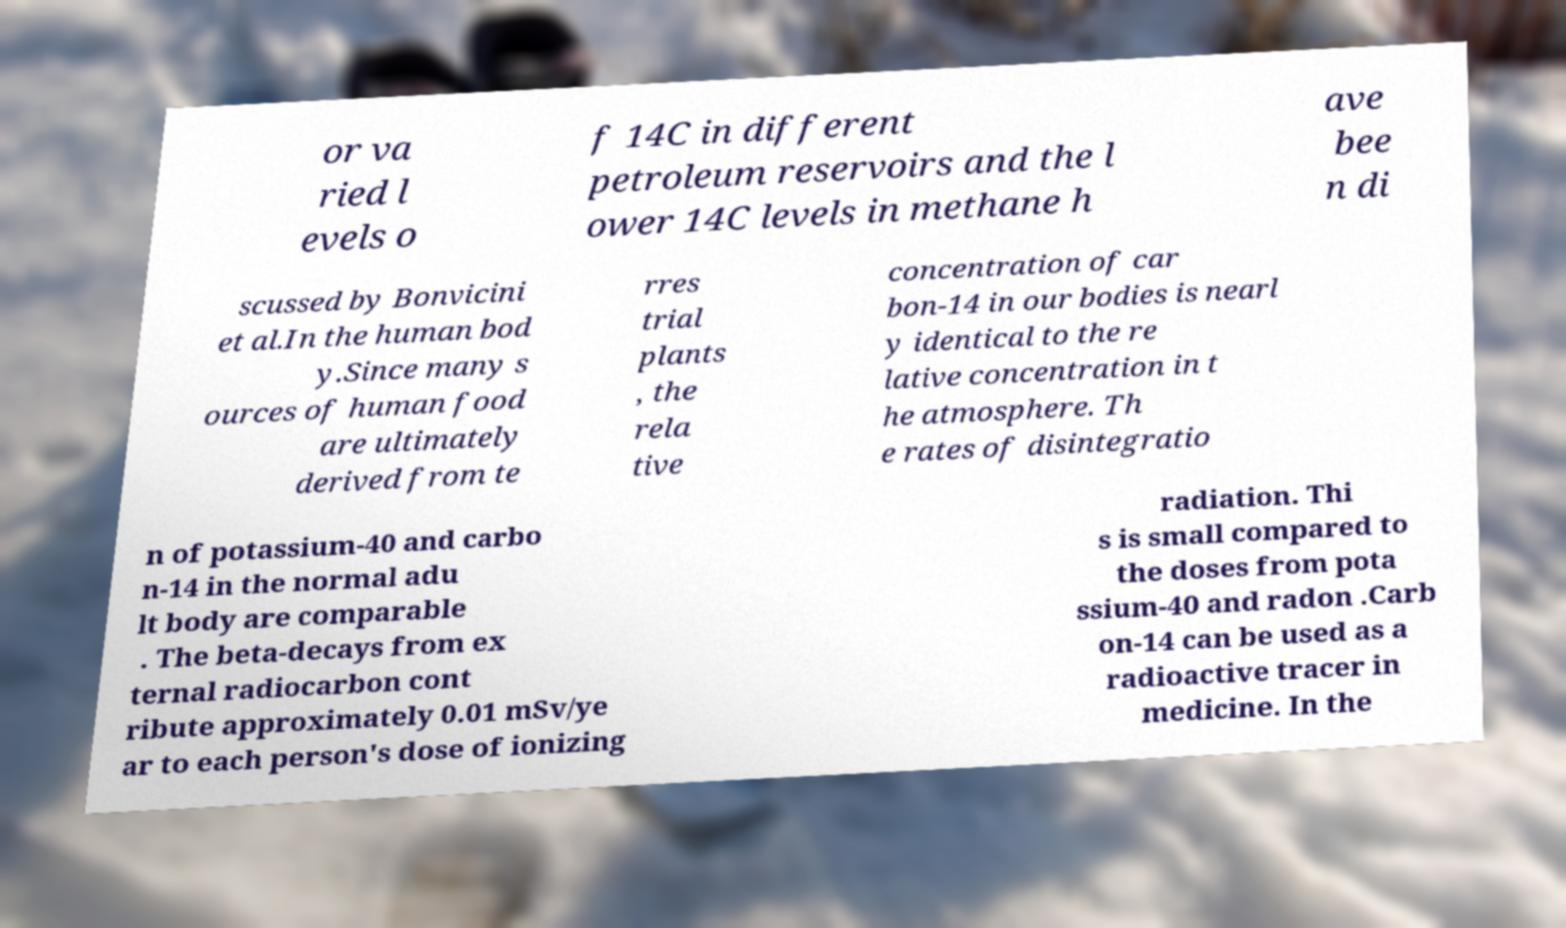For documentation purposes, I need the text within this image transcribed. Could you provide that? or va ried l evels o f 14C in different petroleum reservoirs and the l ower 14C levels in methane h ave bee n di scussed by Bonvicini et al.In the human bod y.Since many s ources of human food are ultimately derived from te rres trial plants , the rela tive concentration of car bon-14 in our bodies is nearl y identical to the re lative concentration in t he atmosphere. Th e rates of disintegratio n of potassium-40 and carbo n-14 in the normal adu lt body are comparable . The beta-decays from ex ternal radiocarbon cont ribute approximately 0.01 mSv/ye ar to each person's dose of ionizing radiation. Thi s is small compared to the doses from pota ssium-40 and radon .Carb on-14 can be used as a radioactive tracer in medicine. In the 